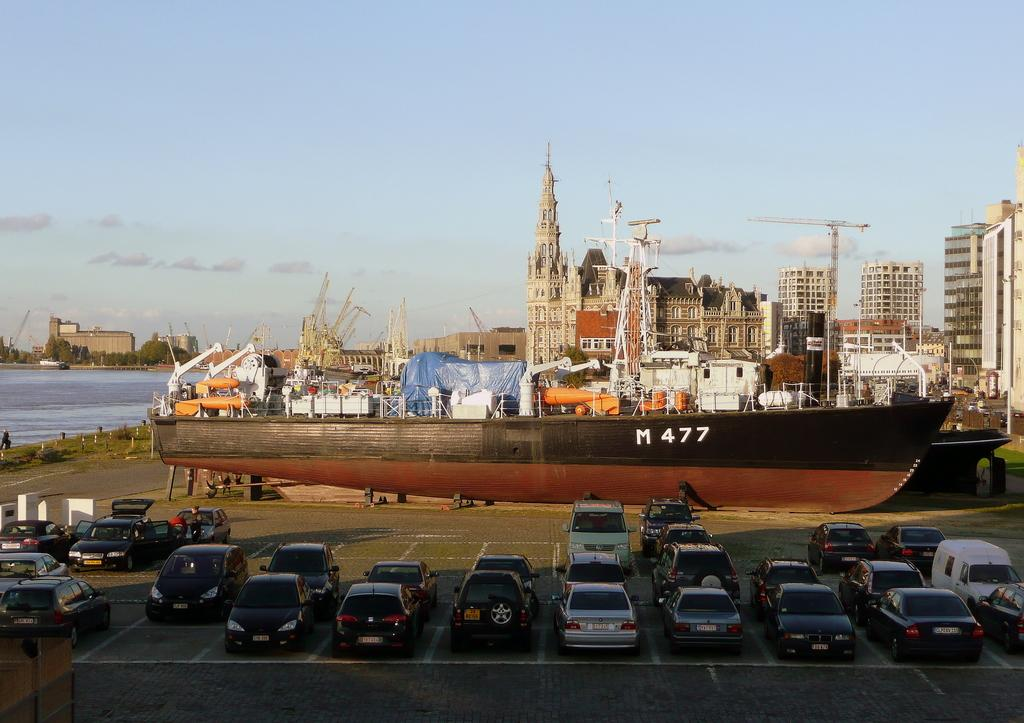What types of transportation are present in the image? There are vehicles on the ground and boats in the image. What structures can be seen in the image? There are buildings in the image. What are the poles used for in the image? The purpose of the poles is not specified in the image. What natural element is visible in the image? There is water visible in the image. What type of vegetation is present in the image? There are trees in the image. What other unspecified objects can be seen in the image? There are some unspecified objects in the image. What is visible in the background of the image? The sky is visible in the background of the image. What type of war is being depicted in the image? There is no depiction of war in the image; it features vehicles, boats, buildings, poles, water, trees, unspecified objects, and a visible sky. How does the wave affect the boats in the image? There is no wave present in the image; it features water but no waves. What type of chain can be seen connecting the buildings in the image? There is no chain connecting the buildings in the image; it features buildings but no chains. 